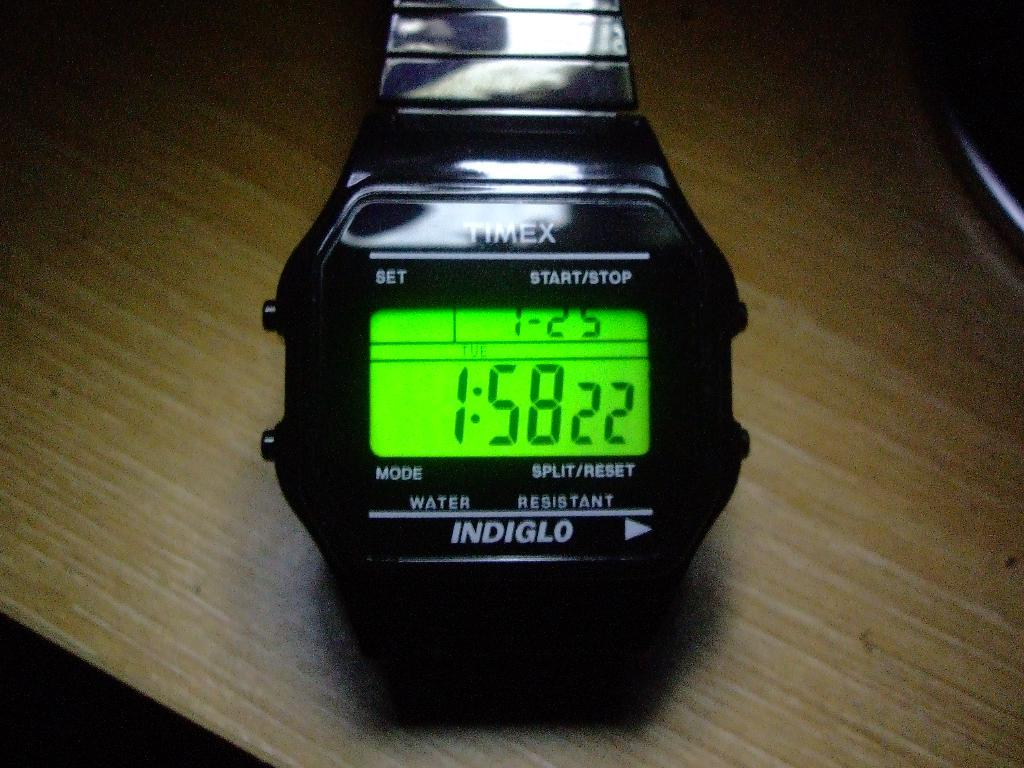<image>
Relay a brief, clear account of the picture shown. A Timex stopwatch has a glowing green screen. 